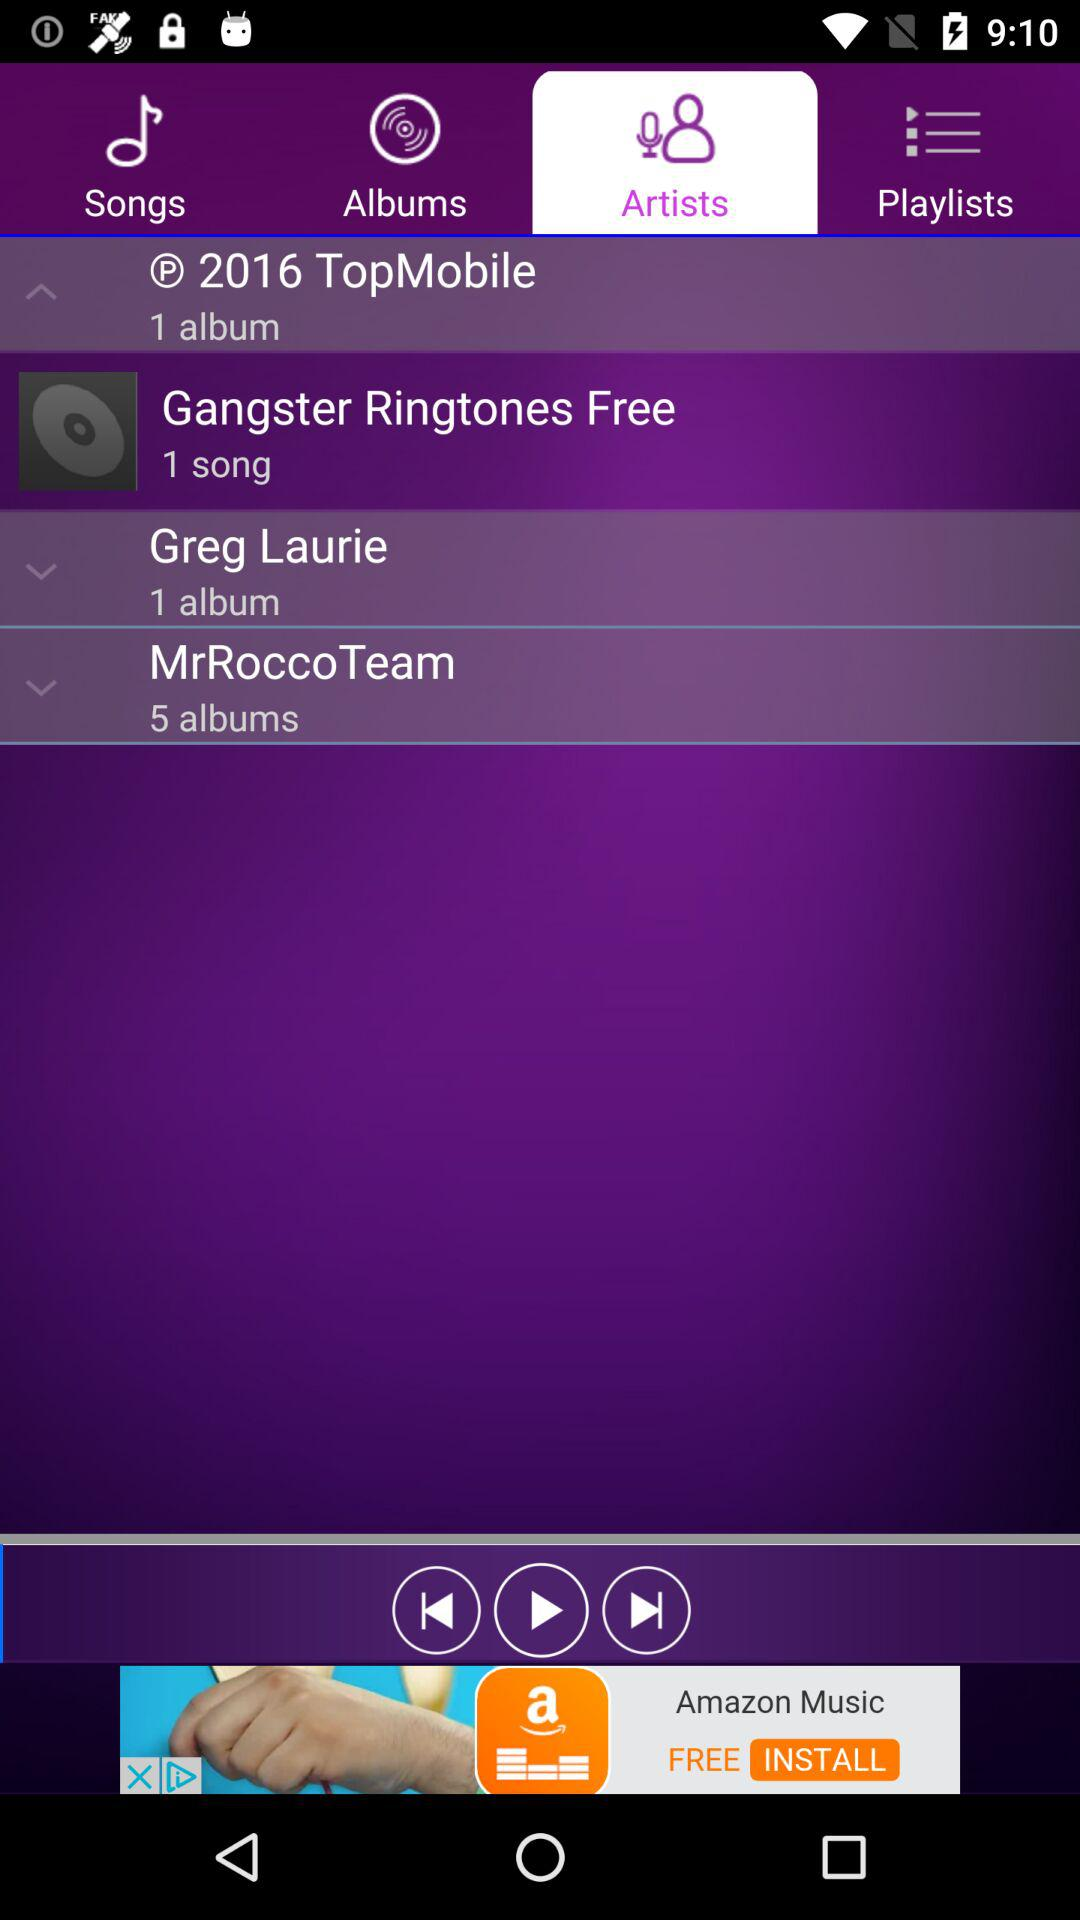What is the mentioned year with TopMobile? The mentioned year is 2016. 